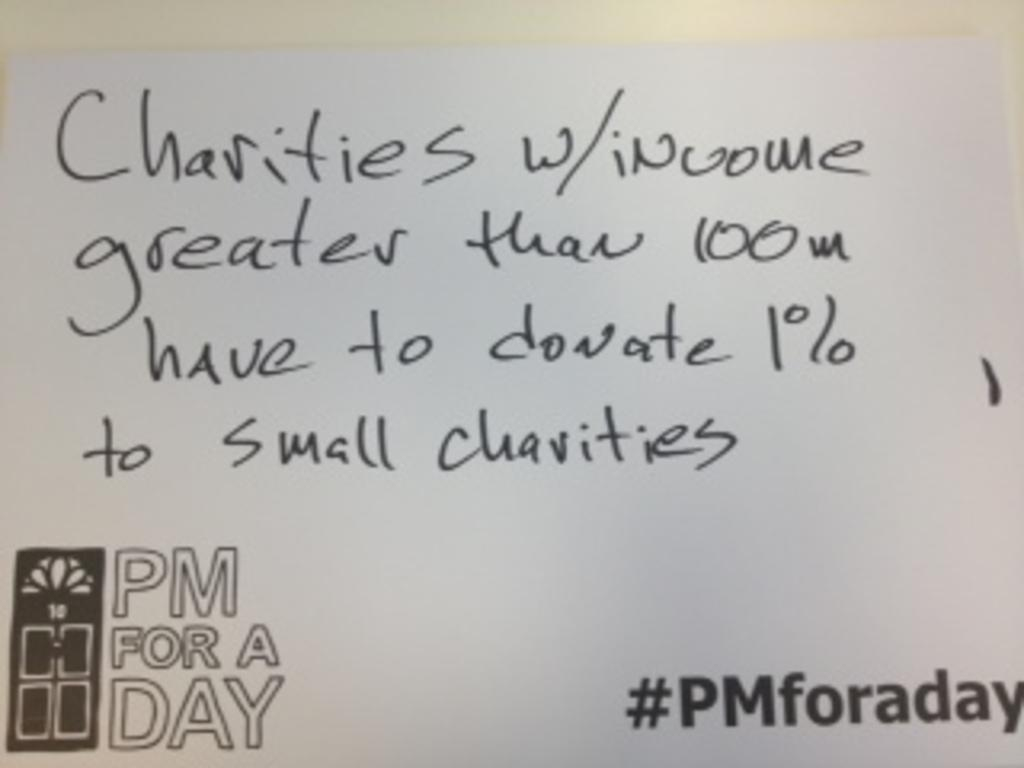<image>
Summarize the visual content of the image. A note reading "Charities w/income greater than 100m" 